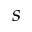<formula> <loc_0><loc_0><loc_500><loc_500>s</formula> 